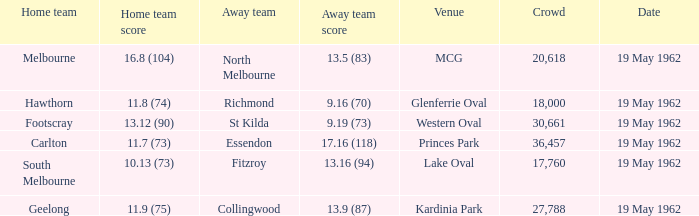What day is the western oval event taking place? 19 May 1962. 